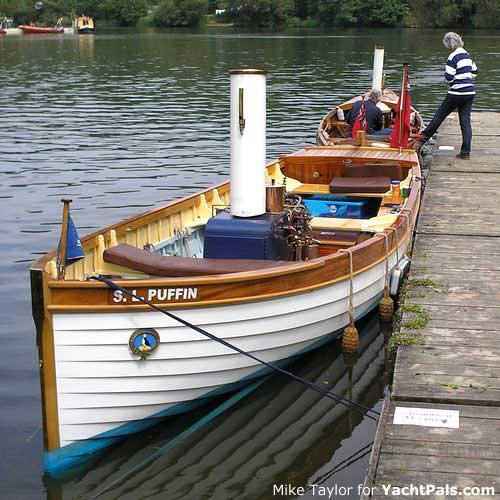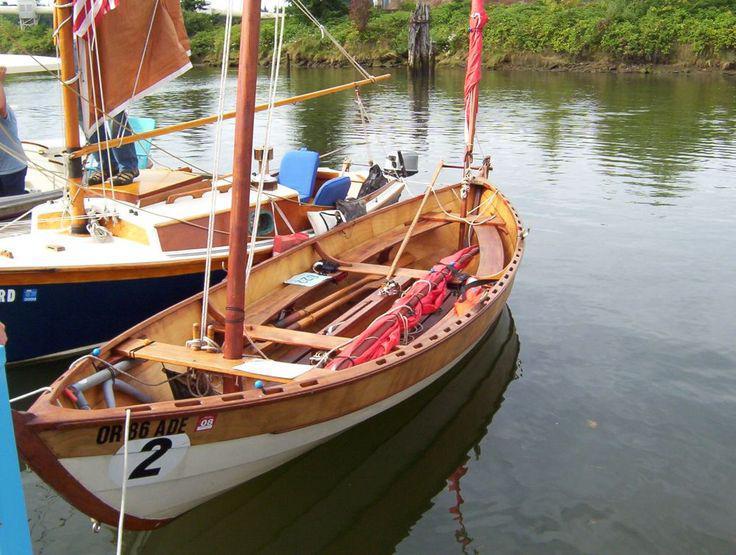The first image is the image on the left, the second image is the image on the right. Assess this claim about the two images: "The left image shows exactly one boat, which has an upright sail and one rider inside.". Correct or not? Answer yes or no. No. 